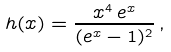<formula> <loc_0><loc_0><loc_500><loc_500>h ( x ) = \frac { x ^ { 4 } \, e ^ { x } } { ( e ^ { x } - 1 ) ^ { 2 } } \, ,</formula> 